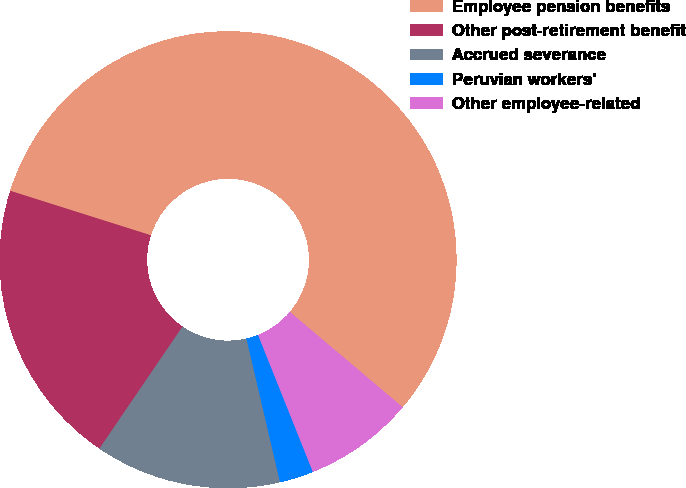Convert chart. <chart><loc_0><loc_0><loc_500><loc_500><pie_chart><fcel>Employee pension benefits<fcel>Other post-retirement benefit<fcel>Accrued severance<fcel>Peruvian workers'<fcel>Other employee-related<nl><fcel>56.29%<fcel>20.36%<fcel>13.17%<fcel>2.4%<fcel>7.78%<nl></chart> 